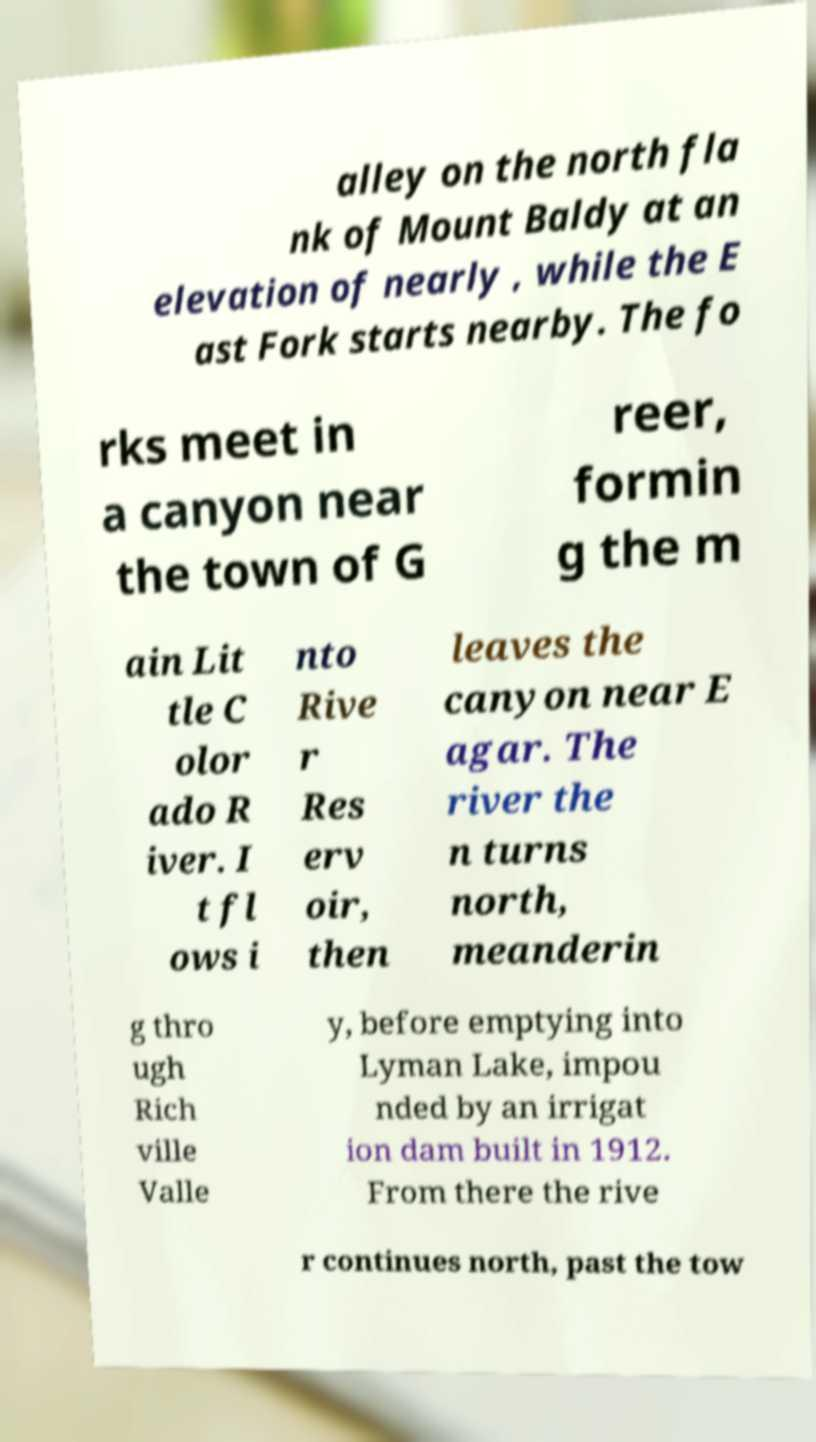Please identify and transcribe the text found in this image. alley on the north fla nk of Mount Baldy at an elevation of nearly , while the E ast Fork starts nearby. The fo rks meet in a canyon near the town of G reer, formin g the m ain Lit tle C olor ado R iver. I t fl ows i nto Rive r Res erv oir, then leaves the canyon near E agar. The river the n turns north, meanderin g thro ugh Rich ville Valle y, before emptying into Lyman Lake, impou nded by an irrigat ion dam built in 1912. From there the rive r continues north, past the tow 